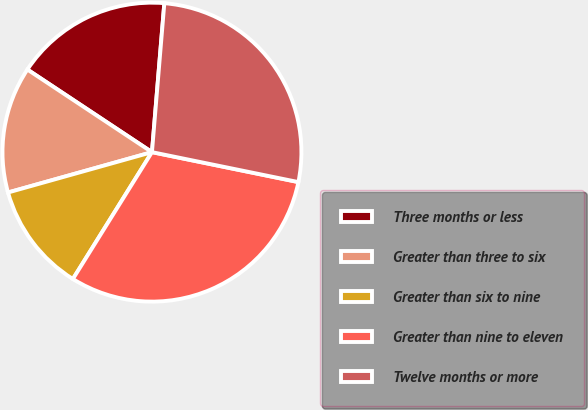Convert chart. <chart><loc_0><loc_0><loc_500><loc_500><pie_chart><fcel>Three months or less<fcel>Greater than three to six<fcel>Greater than six to nine<fcel>Greater than nine to eleven<fcel>Twelve months or more<nl><fcel>17.0%<fcel>13.67%<fcel>11.78%<fcel>30.66%<fcel>26.89%<nl></chart> 